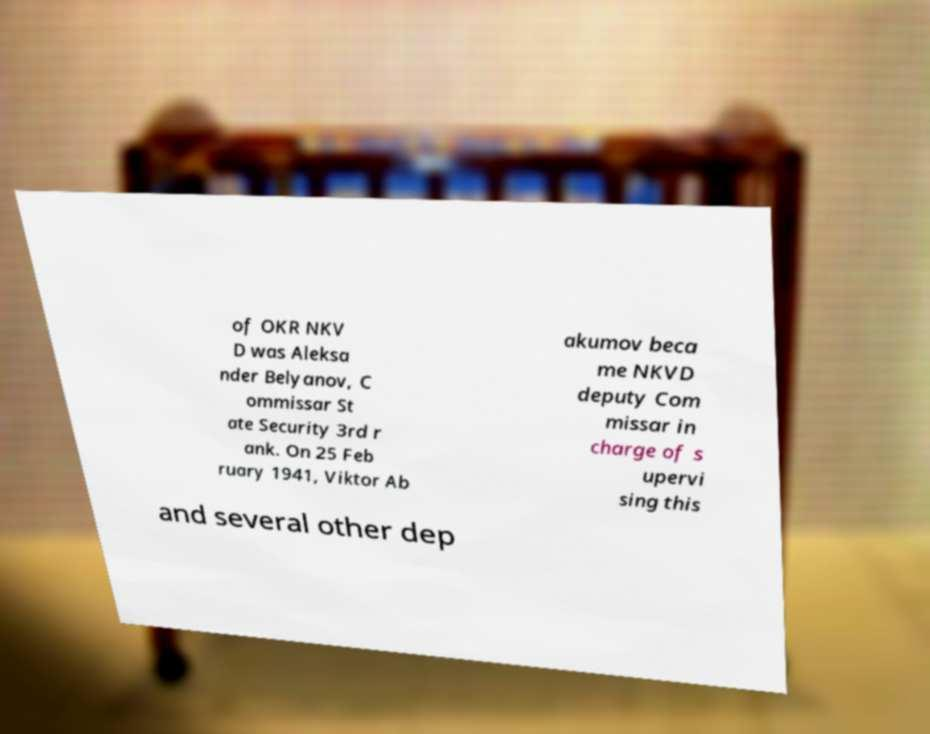For documentation purposes, I need the text within this image transcribed. Could you provide that? of OKR NKV D was Aleksa nder Belyanov, C ommissar St ate Security 3rd r ank. On 25 Feb ruary 1941, Viktor Ab akumov beca me NKVD deputy Com missar in charge of s upervi sing this and several other dep 